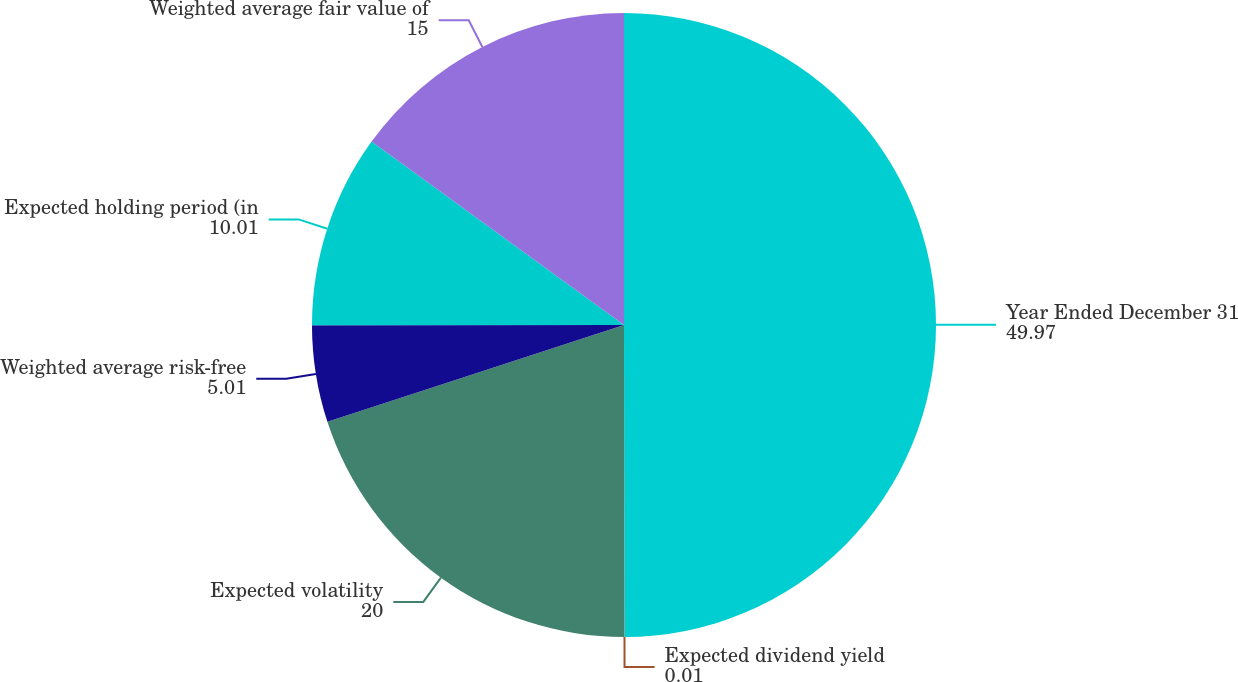Convert chart to OTSL. <chart><loc_0><loc_0><loc_500><loc_500><pie_chart><fcel>Year Ended December 31<fcel>Expected dividend yield<fcel>Expected volatility<fcel>Weighted average risk-free<fcel>Expected holding period (in<fcel>Weighted average fair value of<nl><fcel>49.97%<fcel>0.01%<fcel>20.0%<fcel>5.01%<fcel>10.01%<fcel>15.0%<nl></chart> 